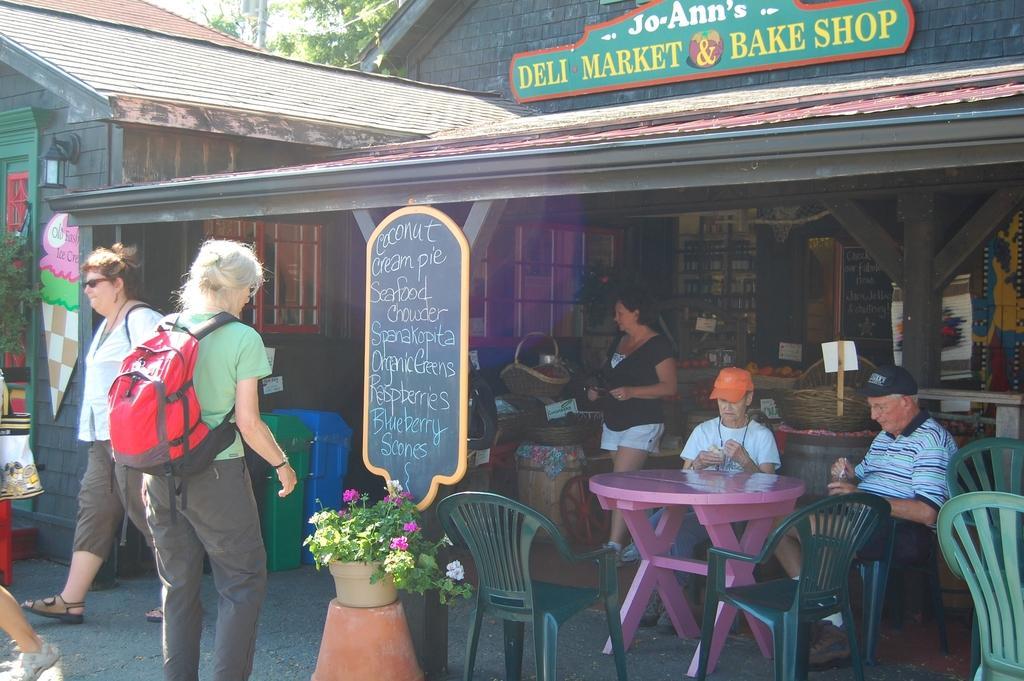How would you summarize this image in a sentence or two? I can see in this image a group of people among them, few are sitting on a chair in front of a table and few or walking on the ground. I can see there is a shop and a black color board. 